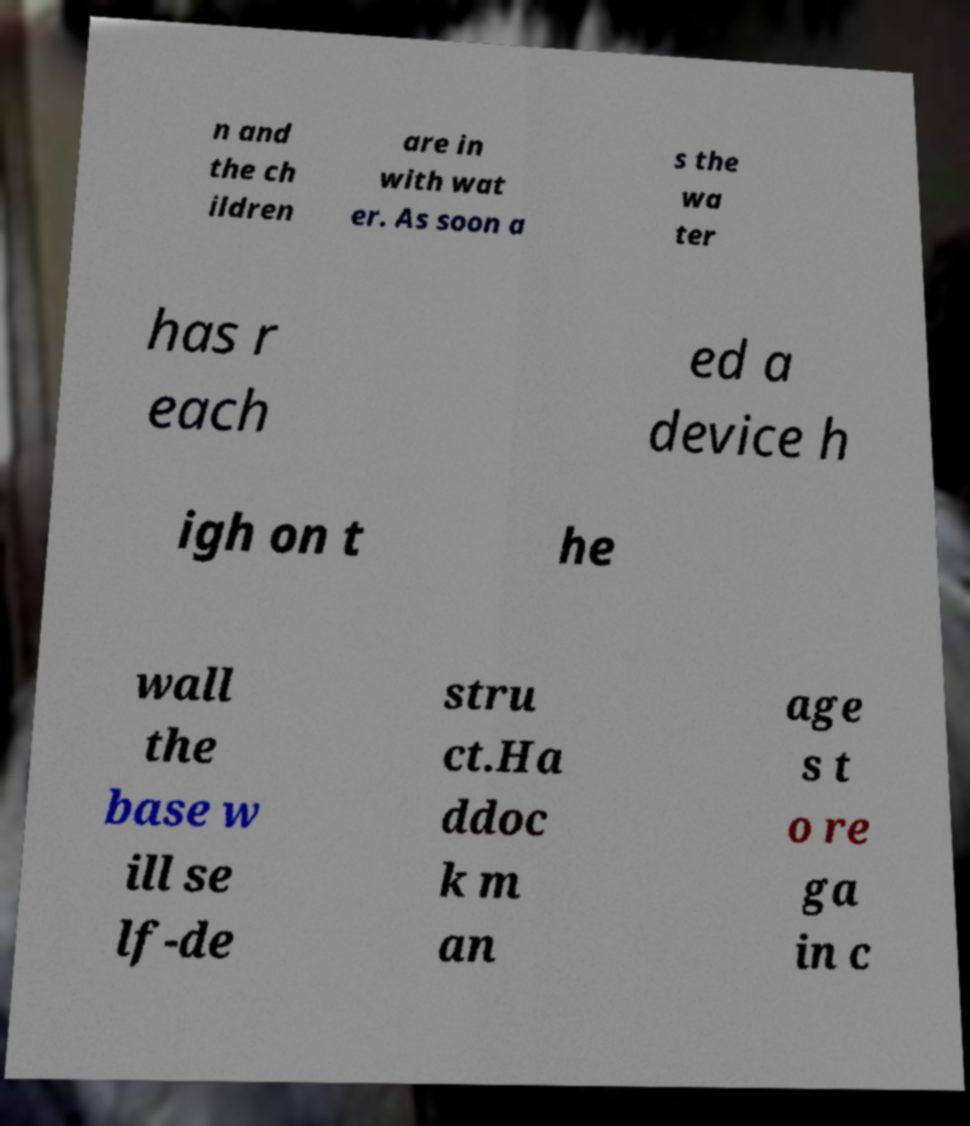Could you assist in decoding the text presented in this image and type it out clearly? n and the ch ildren are in with wat er. As soon a s the wa ter has r each ed a device h igh on t he wall the base w ill se lf-de stru ct.Ha ddoc k m an age s t o re ga in c 